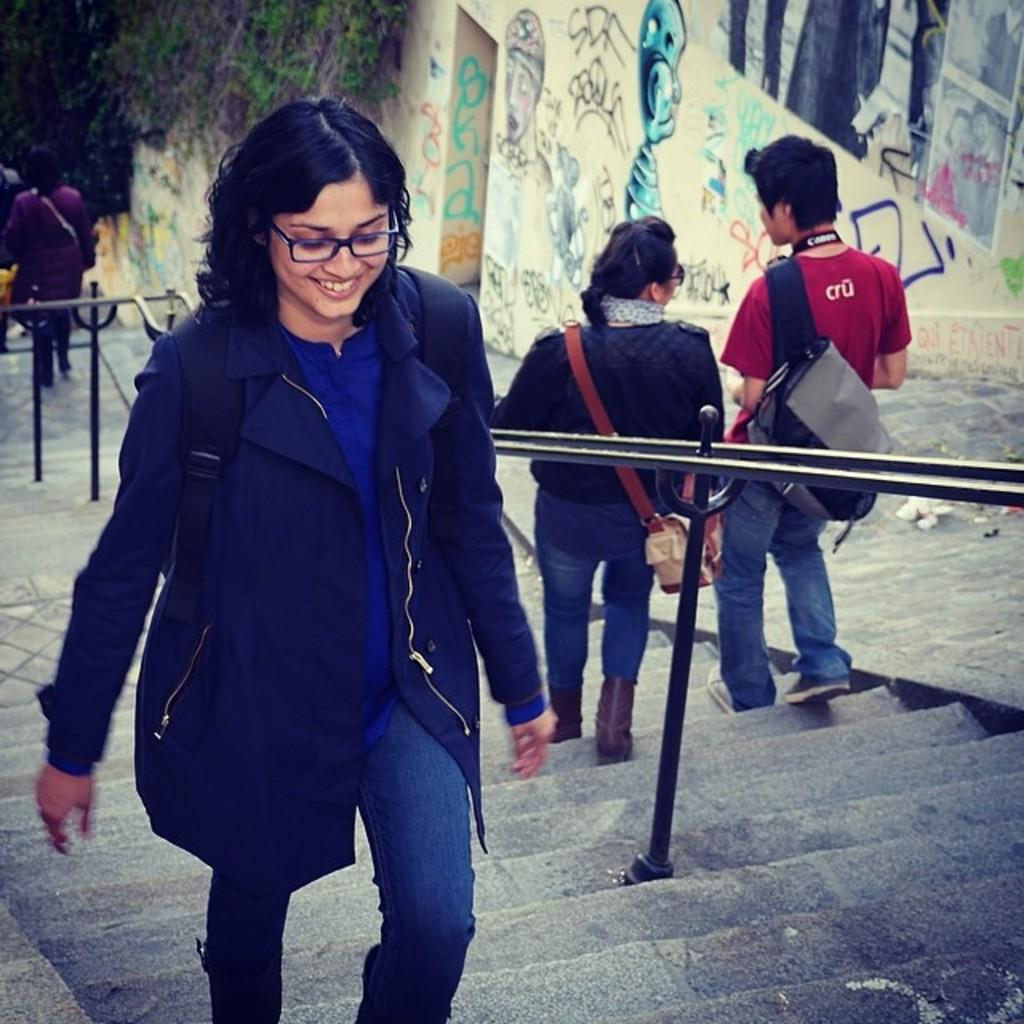How many people are in the image? There are people in the image, but the exact number is not specified. Can you describe the facial expression of one of the people? One person is smiling in the image. What are two people doing in the image? Two people are carrying bags in the image. What objects can be seen in the image that are used for support or structure? There are rods and steps in the image. What type of artwork is present on the wall? There is a painting on the wall in the image. What type of decorations are present on the wall? There are posters on the wall in the image. What can be seen in the background of the image? Leaves are visible in the background of the image. What type of creature is playing volleyball in the image? There is no creature playing volleyball in the image; it does not depict any sports or games. What type of beverage is being served in the image? There is no beverage, such as eggnog, present in the image. 